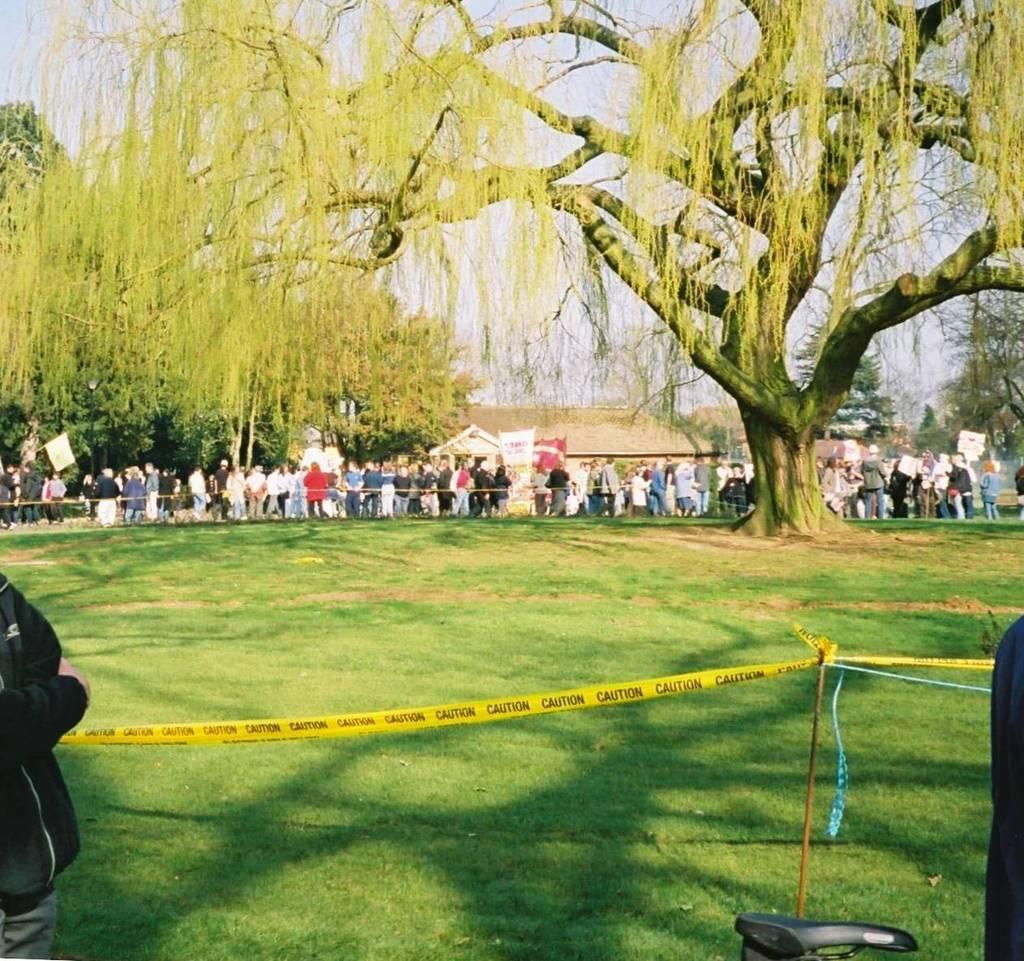How would you summarize this image in a sentence or two? In this picture we can see grass at the bottom, there are some people standing in the middle, in the background we can see trees and a house, there is a ribbon in the front, we can see the sky at the top of the picture, there is a flag and a hoarding in the middle. 